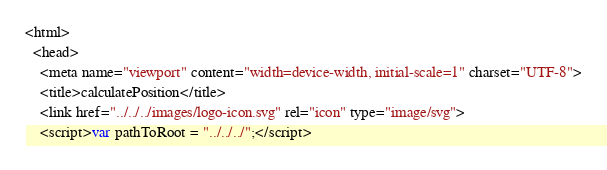<code> <loc_0><loc_0><loc_500><loc_500><_HTML_><html>
  <head>
    <meta name="viewport" content="width=device-width, initial-scale=1" charset="UTF-8">
    <title>calculatePosition</title>
    <link href="../../../images/logo-icon.svg" rel="icon" type="image/svg">
    <script>var pathToRoot = "../../../";</script></code> 